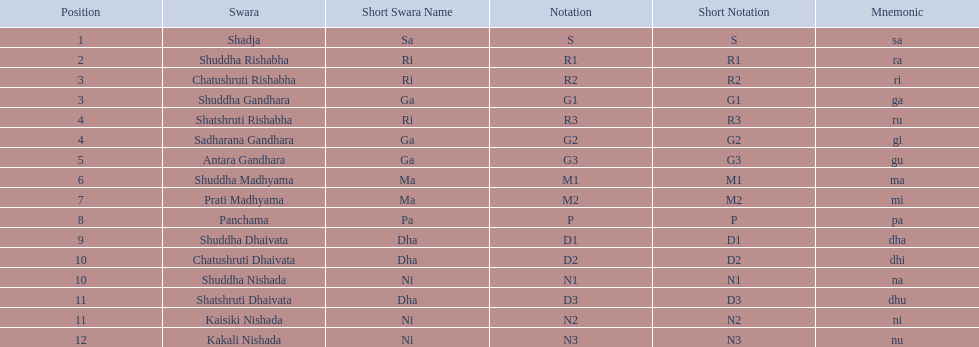Which swara follows immediately after antara gandhara? Shuddha Madhyama. 